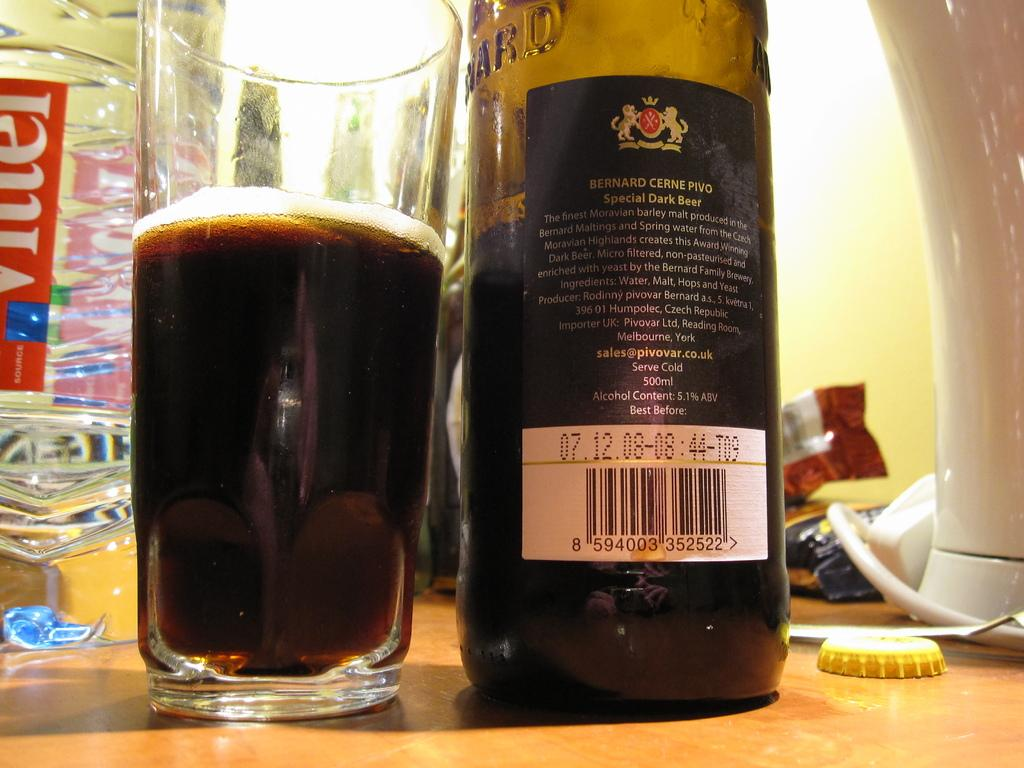<image>
Write a terse but informative summary of the picture. A half empty bottle of special dark beer is next to a glass that is half full. 